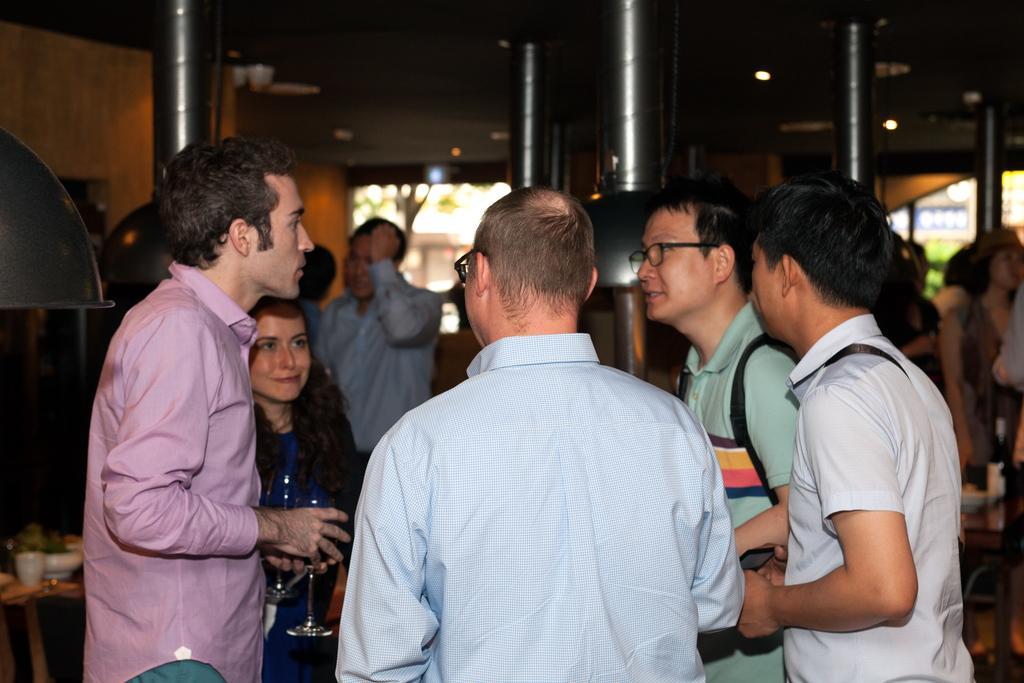Can you describe this image briefly? In this picture we can see some persons standing and discussing. Behind there are some steel pillars and wall. 